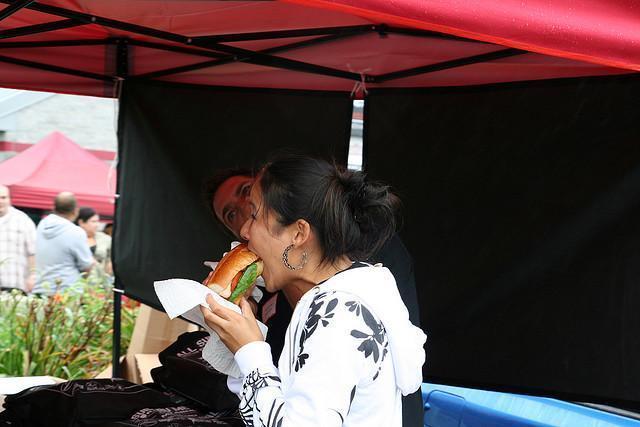How many people are in the photo?
Give a very brief answer. 3. 